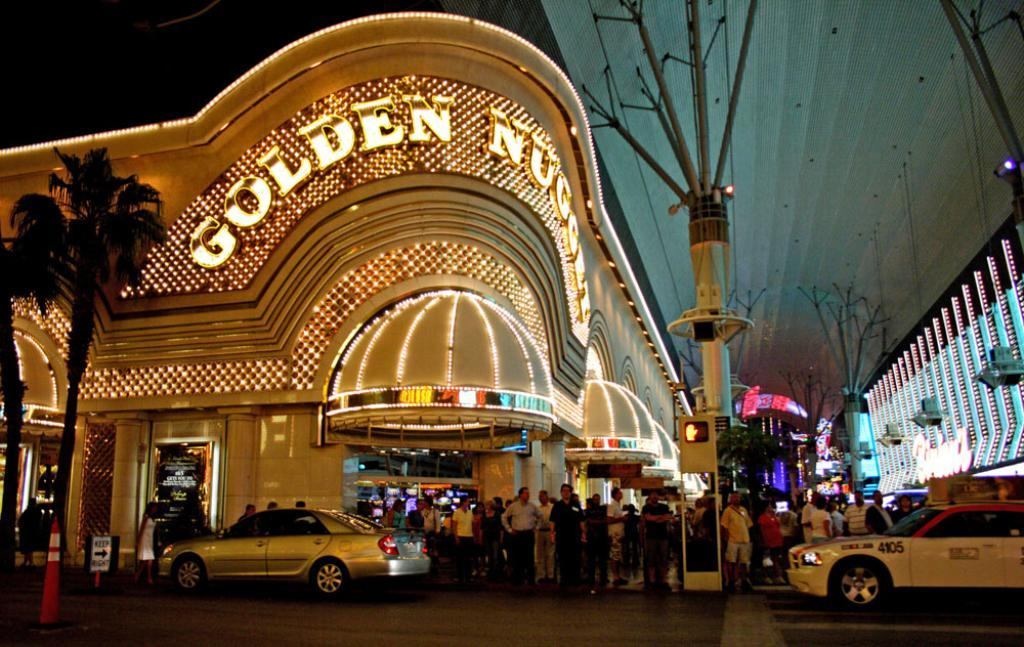<image>
Create a compact narrative representing the image presented. A building with lots of lights on it says Golden Nuggets across the top. 